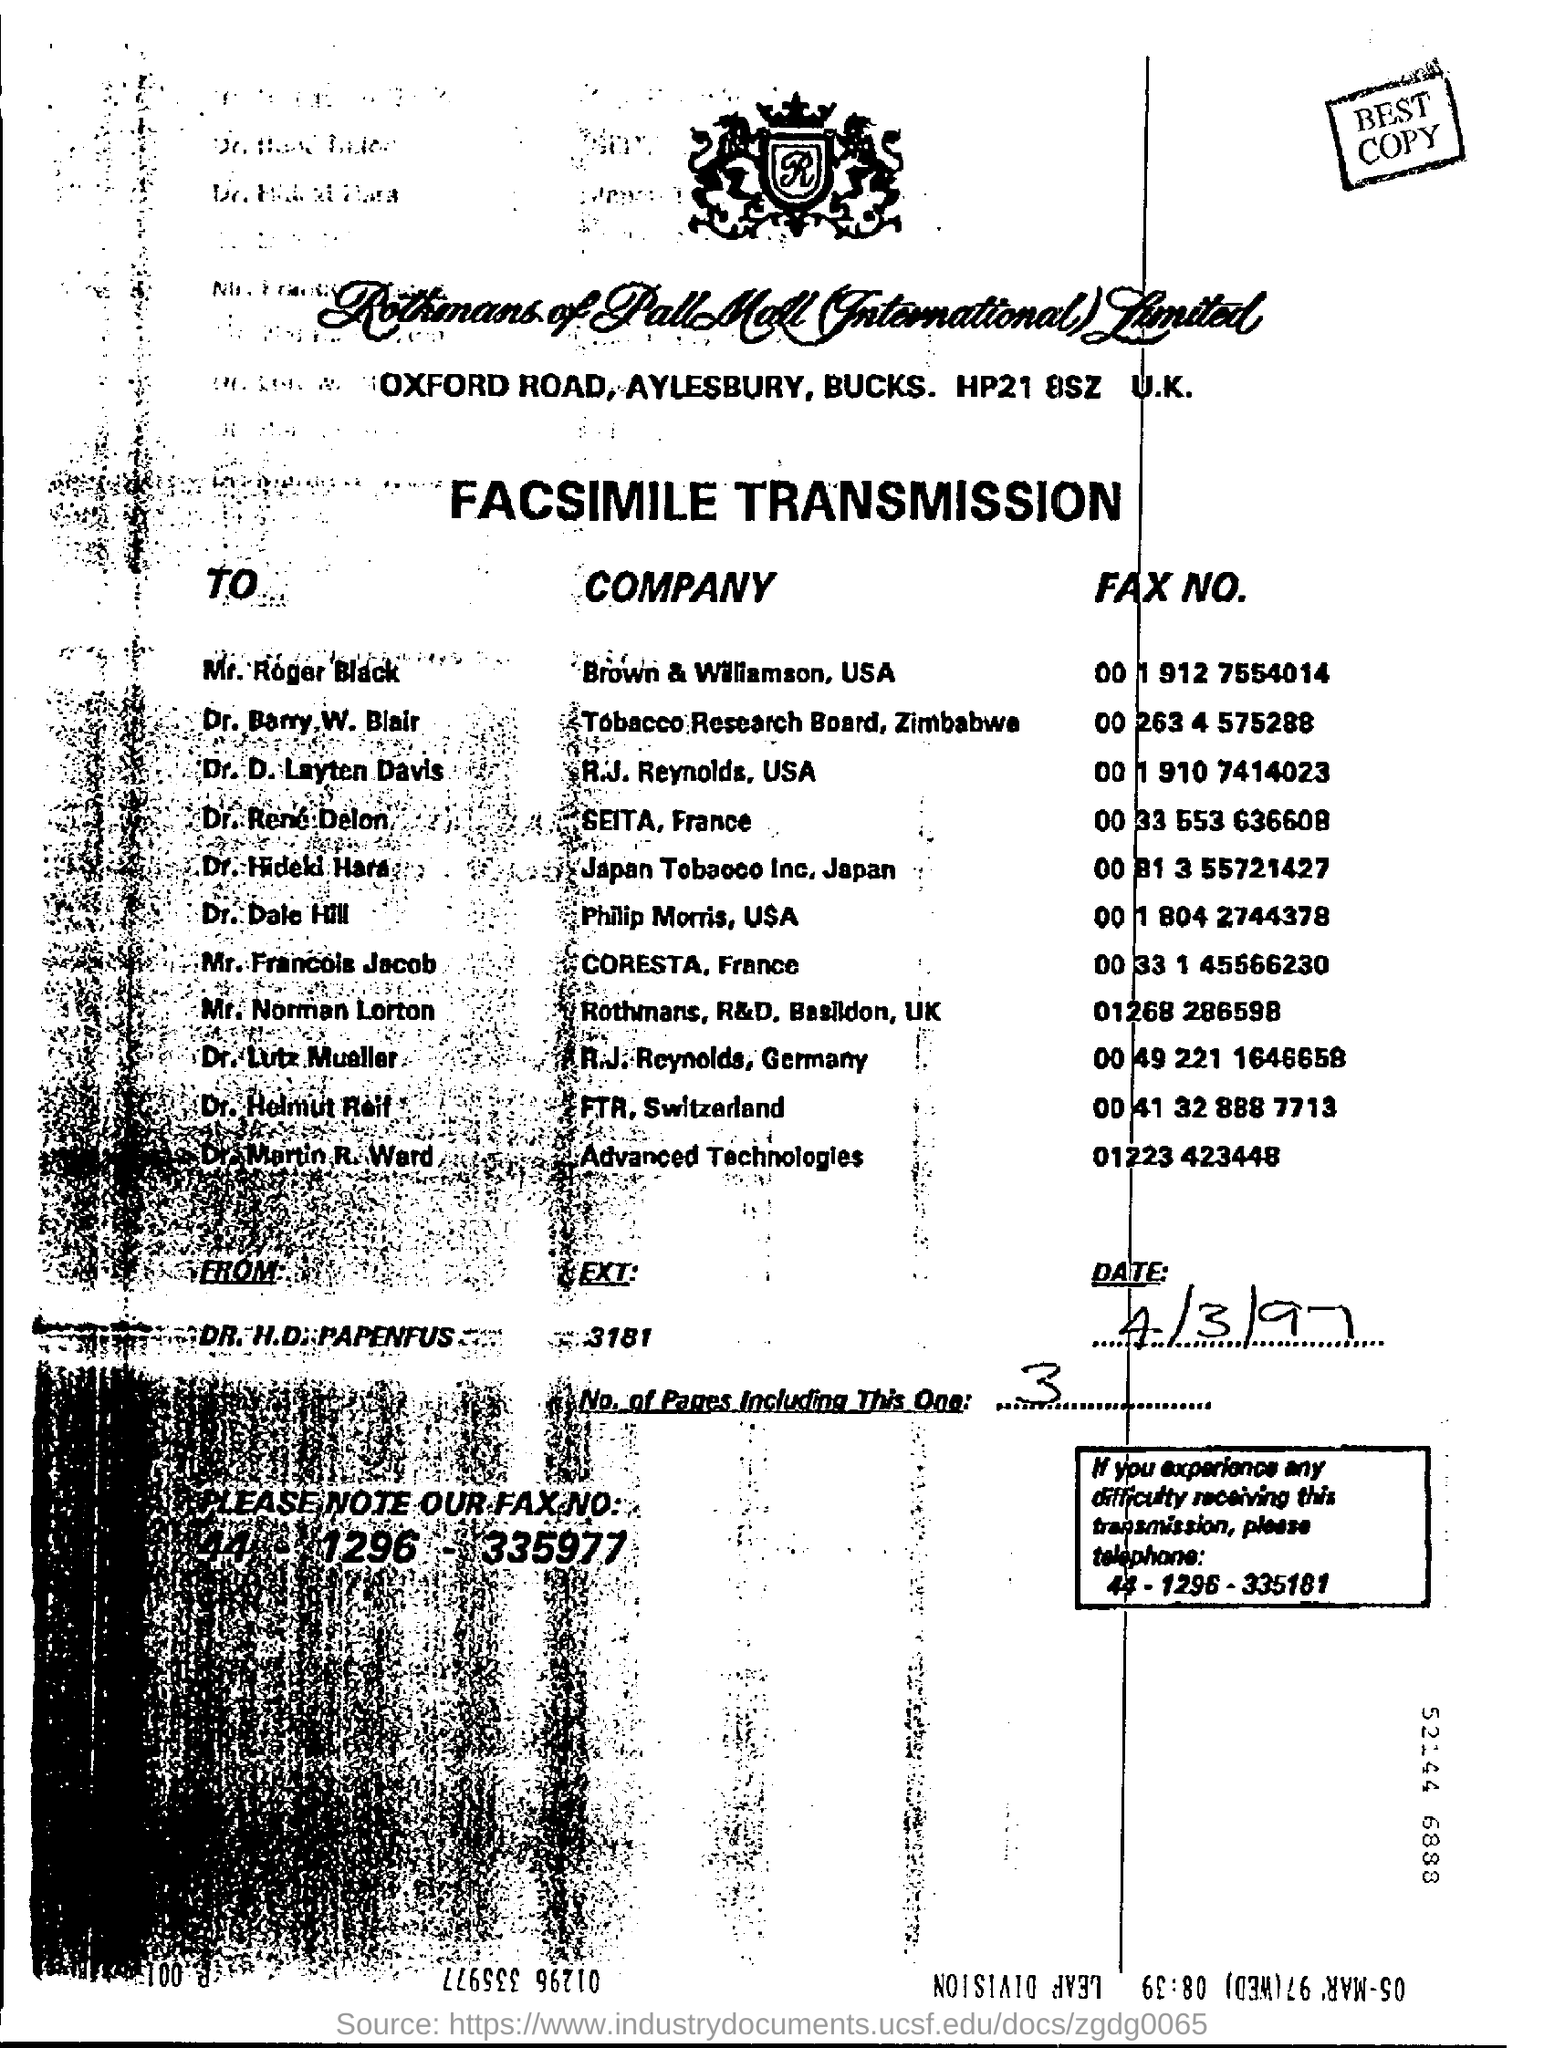Point out several critical features in this image. The text located in a rectangular box at the top of the page is labeled 'BEST COPY.' The letter 'R' is written on top of the page in the design. 